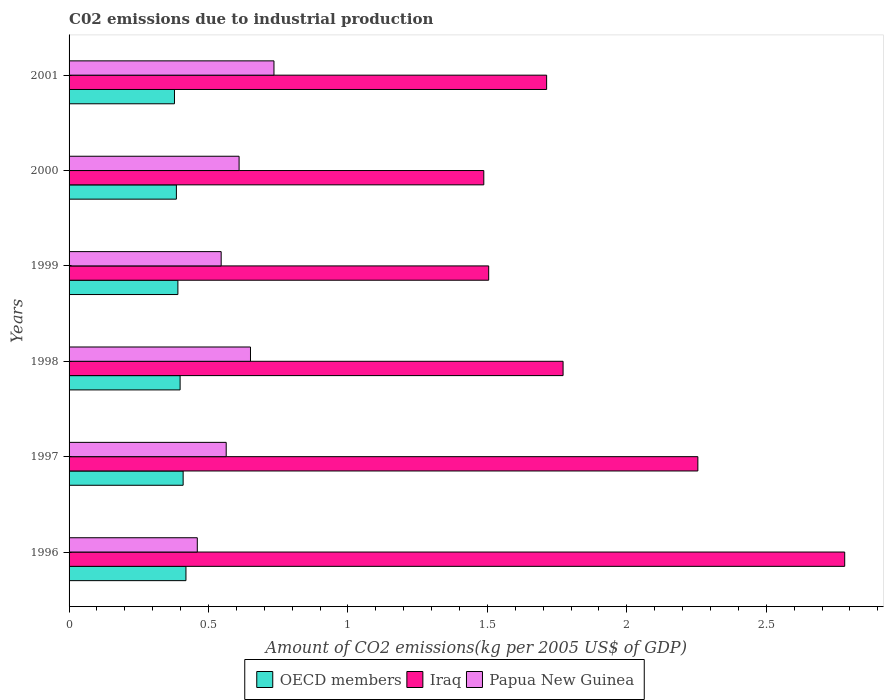How many different coloured bars are there?
Your answer should be very brief. 3. How many groups of bars are there?
Offer a terse response. 6. Are the number of bars per tick equal to the number of legend labels?
Make the answer very short. Yes. How many bars are there on the 1st tick from the top?
Offer a very short reply. 3. How many bars are there on the 1st tick from the bottom?
Your answer should be compact. 3. What is the amount of CO2 emitted due to industrial production in OECD members in 1999?
Your response must be concise. 0.39. Across all years, what is the maximum amount of CO2 emitted due to industrial production in Papua New Guinea?
Give a very brief answer. 0.73. Across all years, what is the minimum amount of CO2 emitted due to industrial production in Papua New Guinea?
Make the answer very short. 0.46. In which year was the amount of CO2 emitted due to industrial production in Iraq maximum?
Offer a terse response. 1996. In which year was the amount of CO2 emitted due to industrial production in Iraq minimum?
Provide a short and direct response. 2000. What is the total amount of CO2 emitted due to industrial production in OECD members in the graph?
Provide a succinct answer. 2.38. What is the difference between the amount of CO2 emitted due to industrial production in Papua New Guinea in 1997 and that in 1998?
Offer a terse response. -0.09. What is the difference between the amount of CO2 emitted due to industrial production in OECD members in 2000 and the amount of CO2 emitted due to industrial production in Papua New Guinea in 1997?
Offer a very short reply. -0.18. What is the average amount of CO2 emitted due to industrial production in OECD members per year?
Offer a terse response. 0.4. In the year 1998, what is the difference between the amount of CO2 emitted due to industrial production in Papua New Guinea and amount of CO2 emitted due to industrial production in OECD members?
Offer a terse response. 0.25. In how many years, is the amount of CO2 emitted due to industrial production in Iraq greater than 2.2 kg?
Your answer should be compact. 2. What is the ratio of the amount of CO2 emitted due to industrial production in Iraq in 1997 to that in 2001?
Provide a short and direct response. 1.32. Is the amount of CO2 emitted due to industrial production in Iraq in 1997 less than that in 1999?
Keep it short and to the point. No. Is the difference between the amount of CO2 emitted due to industrial production in Papua New Guinea in 1997 and 2001 greater than the difference between the amount of CO2 emitted due to industrial production in OECD members in 1997 and 2001?
Offer a very short reply. No. What is the difference between the highest and the second highest amount of CO2 emitted due to industrial production in Iraq?
Ensure brevity in your answer.  0.53. What is the difference between the highest and the lowest amount of CO2 emitted due to industrial production in OECD members?
Keep it short and to the point. 0.04. Is the sum of the amount of CO2 emitted due to industrial production in Papua New Guinea in 1996 and 1998 greater than the maximum amount of CO2 emitted due to industrial production in OECD members across all years?
Your answer should be very brief. Yes. What does the 1st bar from the top in 1997 represents?
Provide a short and direct response. Papua New Guinea. What does the 1st bar from the bottom in 1997 represents?
Your answer should be compact. OECD members. How many bars are there?
Your response must be concise. 18. Are all the bars in the graph horizontal?
Give a very brief answer. Yes. Does the graph contain grids?
Ensure brevity in your answer.  No. What is the title of the graph?
Your response must be concise. C02 emissions due to industrial production. What is the label or title of the X-axis?
Offer a very short reply. Amount of CO2 emissions(kg per 2005 US$ of GDP). What is the Amount of CO2 emissions(kg per 2005 US$ of GDP) in OECD members in 1996?
Keep it short and to the point. 0.42. What is the Amount of CO2 emissions(kg per 2005 US$ of GDP) in Iraq in 1996?
Offer a very short reply. 2.78. What is the Amount of CO2 emissions(kg per 2005 US$ of GDP) of Papua New Guinea in 1996?
Provide a succinct answer. 0.46. What is the Amount of CO2 emissions(kg per 2005 US$ of GDP) of OECD members in 1997?
Ensure brevity in your answer.  0.41. What is the Amount of CO2 emissions(kg per 2005 US$ of GDP) of Iraq in 1997?
Keep it short and to the point. 2.25. What is the Amount of CO2 emissions(kg per 2005 US$ of GDP) in Papua New Guinea in 1997?
Offer a very short reply. 0.56. What is the Amount of CO2 emissions(kg per 2005 US$ of GDP) in OECD members in 1998?
Offer a terse response. 0.4. What is the Amount of CO2 emissions(kg per 2005 US$ of GDP) of Iraq in 1998?
Your answer should be very brief. 1.77. What is the Amount of CO2 emissions(kg per 2005 US$ of GDP) in Papua New Guinea in 1998?
Your answer should be very brief. 0.65. What is the Amount of CO2 emissions(kg per 2005 US$ of GDP) of OECD members in 1999?
Your answer should be compact. 0.39. What is the Amount of CO2 emissions(kg per 2005 US$ of GDP) of Iraq in 1999?
Provide a succinct answer. 1.5. What is the Amount of CO2 emissions(kg per 2005 US$ of GDP) of Papua New Guinea in 1999?
Your response must be concise. 0.55. What is the Amount of CO2 emissions(kg per 2005 US$ of GDP) in OECD members in 2000?
Your response must be concise. 0.38. What is the Amount of CO2 emissions(kg per 2005 US$ of GDP) of Iraq in 2000?
Offer a terse response. 1.49. What is the Amount of CO2 emissions(kg per 2005 US$ of GDP) of Papua New Guinea in 2000?
Ensure brevity in your answer.  0.61. What is the Amount of CO2 emissions(kg per 2005 US$ of GDP) in OECD members in 2001?
Provide a succinct answer. 0.38. What is the Amount of CO2 emissions(kg per 2005 US$ of GDP) of Iraq in 2001?
Your answer should be compact. 1.71. What is the Amount of CO2 emissions(kg per 2005 US$ of GDP) of Papua New Guinea in 2001?
Make the answer very short. 0.73. Across all years, what is the maximum Amount of CO2 emissions(kg per 2005 US$ of GDP) of OECD members?
Make the answer very short. 0.42. Across all years, what is the maximum Amount of CO2 emissions(kg per 2005 US$ of GDP) of Iraq?
Your answer should be very brief. 2.78. Across all years, what is the maximum Amount of CO2 emissions(kg per 2005 US$ of GDP) in Papua New Guinea?
Provide a short and direct response. 0.73. Across all years, what is the minimum Amount of CO2 emissions(kg per 2005 US$ of GDP) of OECD members?
Your answer should be compact. 0.38. Across all years, what is the minimum Amount of CO2 emissions(kg per 2005 US$ of GDP) in Iraq?
Offer a terse response. 1.49. Across all years, what is the minimum Amount of CO2 emissions(kg per 2005 US$ of GDP) in Papua New Guinea?
Your answer should be compact. 0.46. What is the total Amount of CO2 emissions(kg per 2005 US$ of GDP) of OECD members in the graph?
Provide a short and direct response. 2.38. What is the total Amount of CO2 emissions(kg per 2005 US$ of GDP) of Iraq in the graph?
Offer a terse response. 11.51. What is the total Amount of CO2 emissions(kg per 2005 US$ of GDP) of Papua New Guinea in the graph?
Your response must be concise. 3.56. What is the difference between the Amount of CO2 emissions(kg per 2005 US$ of GDP) in OECD members in 1996 and that in 1997?
Keep it short and to the point. 0.01. What is the difference between the Amount of CO2 emissions(kg per 2005 US$ of GDP) in Iraq in 1996 and that in 1997?
Your response must be concise. 0.53. What is the difference between the Amount of CO2 emissions(kg per 2005 US$ of GDP) of Papua New Guinea in 1996 and that in 1997?
Provide a succinct answer. -0.1. What is the difference between the Amount of CO2 emissions(kg per 2005 US$ of GDP) in OECD members in 1996 and that in 1998?
Provide a short and direct response. 0.02. What is the difference between the Amount of CO2 emissions(kg per 2005 US$ of GDP) of Iraq in 1996 and that in 1998?
Ensure brevity in your answer.  1.01. What is the difference between the Amount of CO2 emissions(kg per 2005 US$ of GDP) of Papua New Guinea in 1996 and that in 1998?
Offer a terse response. -0.19. What is the difference between the Amount of CO2 emissions(kg per 2005 US$ of GDP) in OECD members in 1996 and that in 1999?
Ensure brevity in your answer.  0.03. What is the difference between the Amount of CO2 emissions(kg per 2005 US$ of GDP) in Iraq in 1996 and that in 1999?
Your response must be concise. 1.28. What is the difference between the Amount of CO2 emissions(kg per 2005 US$ of GDP) of Papua New Guinea in 1996 and that in 1999?
Your answer should be compact. -0.09. What is the difference between the Amount of CO2 emissions(kg per 2005 US$ of GDP) of OECD members in 1996 and that in 2000?
Keep it short and to the point. 0.03. What is the difference between the Amount of CO2 emissions(kg per 2005 US$ of GDP) in Iraq in 1996 and that in 2000?
Your response must be concise. 1.29. What is the difference between the Amount of CO2 emissions(kg per 2005 US$ of GDP) of Papua New Guinea in 1996 and that in 2000?
Ensure brevity in your answer.  -0.15. What is the difference between the Amount of CO2 emissions(kg per 2005 US$ of GDP) in OECD members in 1996 and that in 2001?
Your answer should be very brief. 0.04. What is the difference between the Amount of CO2 emissions(kg per 2005 US$ of GDP) of Iraq in 1996 and that in 2001?
Provide a succinct answer. 1.07. What is the difference between the Amount of CO2 emissions(kg per 2005 US$ of GDP) in Papua New Guinea in 1996 and that in 2001?
Offer a terse response. -0.27. What is the difference between the Amount of CO2 emissions(kg per 2005 US$ of GDP) in OECD members in 1997 and that in 1998?
Offer a terse response. 0.01. What is the difference between the Amount of CO2 emissions(kg per 2005 US$ of GDP) of Iraq in 1997 and that in 1998?
Keep it short and to the point. 0.48. What is the difference between the Amount of CO2 emissions(kg per 2005 US$ of GDP) in Papua New Guinea in 1997 and that in 1998?
Keep it short and to the point. -0.09. What is the difference between the Amount of CO2 emissions(kg per 2005 US$ of GDP) in OECD members in 1997 and that in 1999?
Give a very brief answer. 0.02. What is the difference between the Amount of CO2 emissions(kg per 2005 US$ of GDP) in Iraq in 1997 and that in 1999?
Ensure brevity in your answer.  0.75. What is the difference between the Amount of CO2 emissions(kg per 2005 US$ of GDP) of Papua New Guinea in 1997 and that in 1999?
Your answer should be compact. 0.02. What is the difference between the Amount of CO2 emissions(kg per 2005 US$ of GDP) in OECD members in 1997 and that in 2000?
Offer a very short reply. 0.02. What is the difference between the Amount of CO2 emissions(kg per 2005 US$ of GDP) in Iraq in 1997 and that in 2000?
Give a very brief answer. 0.77. What is the difference between the Amount of CO2 emissions(kg per 2005 US$ of GDP) of Papua New Guinea in 1997 and that in 2000?
Offer a terse response. -0.05. What is the difference between the Amount of CO2 emissions(kg per 2005 US$ of GDP) in OECD members in 1997 and that in 2001?
Offer a terse response. 0.03. What is the difference between the Amount of CO2 emissions(kg per 2005 US$ of GDP) of Iraq in 1997 and that in 2001?
Make the answer very short. 0.54. What is the difference between the Amount of CO2 emissions(kg per 2005 US$ of GDP) of Papua New Guinea in 1997 and that in 2001?
Your answer should be very brief. -0.17. What is the difference between the Amount of CO2 emissions(kg per 2005 US$ of GDP) of OECD members in 1998 and that in 1999?
Keep it short and to the point. 0.01. What is the difference between the Amount of CO2 emissions(kg per 2005 US$ of GDP) in Iraq in 1998 and that in 1999?
Your answer should be very brief. 0.27. What is the difference between the Amount of CO2 emissions(kg per 2005 US$ of GDP) of Papua New Guinea in 1998 and that in 1999?
Make the answer very short. 0.11. What is the difference between the Amount of CO2 emissions(kg per 2005 US$ of GDP) of OECD members in 1998 and that in 2000?
Your response must be concise. 0.01. What is the difference between the Amount of CO2 emissions(kg per 2005 US$ of GDP) of Iraq in 1998 and that in 2000?
Your response must be concise. 0.28. What is the difference between the Amount of CO2 emissions(kg per 2005 US$ of GDP) in Papua New Guinea in 1998 and that in 2000?
Offer a very short reply. 0.04. What is the difference between the Amount of CO2 emissions(kg per 2005 US$ of GDP) of OECD members in 1998 and that in 2001?
Offer a terse response. 0.02. What is the difference between the Amount of CO2 emissions(kg per 2005 US$ of GDP) of Iraq in 1998 and that in 2001?
Make the answer very short. 0.06. What is the difference between the Amount of CO2 emissions(kg per 2005 US$ of GDP) of Papua New Guinea in 1998 and that in 2001?
Offer a very short reply. -0.08. What is the difference between the Amount of CO2 emissions(kg per 2005 US$ of GDP) of OECD members in 1999 and that in 2000?
Your answer should be very brief. 0.01. What is the difference between the Amount of CO2 emissions(kg per 2005 US$ of GDP) in Iraq in 1999 and that in 2000?
Your response must be concise. 0.02. What is the difference between the Amount of CO2 emissions(kg per 2005 US$ of GDP) of Papua New Guinea in 1999 and that in 2000?
Offer a terse response. -0.06. What is the difference between the Amount of CO2 emissions(kg per 2005 US$ of GDP) in OECD members in 1999 and that in 2001?
Give a very brief answer. 0.01. What is the difference between the Amount of CO2 emissions(kg per 2005 US$ of GDP) of Iraq in 1999 and that in 2001?
Your answer should be compact. -0.21. What is the difference between the Amount of CO2 emissions(kg per 2005 US$ of GDP) in Papua New Guinea in 1999 and that in 2001?
Offer a very short reply. -0.19. What is the difference between the Amount of CO2 emissions(kg per 2005 US$ of GDP) of OECD members in 2000 and that in 2001?
Ensure brevity in your answer.  0.01. What is the difference between the Amount of CO2 emissions(kg per 2005 US$ of GDP) in Iraq in 2000 and that in 2001?
Your answer should be very brief. -0.23. What is the difference between the Amount of CO2 emissions(kg per 2005 US$ of GDP) of Papua New Guinea in 2000 and that in 2001?
Your answer should be compact. -0.12. What is the difference between the Amount of CO2 emissions(kg per 2005 US$ of GDP) in OECD members in 1996 and the Amount of CO2 emissions(kg per 2005 US$ of GDP) in Iraq in 1997?
Ensure brevity in your answer.  -1.84. What is the difference between the Amount of CO2 emissions(kg per 2005 US$ of GDP) of OECD members in 1996 and the Amount of CO2 emissions(kg per 2005 US$ of GDP) of Papua New Guinea in 1997?
Offer a terse response. -0.14. What is the difference between the Amount of CO2 emissions(kg per 2005 US$ of GDP) in Iraq in 1996 and the Amount of CO2 emissions(kg per 2005 US$ of GDP) in Papua New Guinea in 1997?
Offer a very short reply. 2.22. What is the difference between the Amount of CO2 emissions(kg per 2005 US$ of GDP) in OECD members in 1996 and the Amount of CO2 emissions(kg per 2005 US$ of GDP) in Iraq in 1998?
Offer a very short reply. -1.35. What is the difference between the Amount of CO2 emissions(kg per 2005 US$ of GDP) in OECD members in 1996 and the Amount of CO2 emissions(kg per 2005 US$ of GDP) in Papua New Guinea in 1998?
Your answer should be very brief. -0.23. What is the difference between the Amount of CO2 emissions(kg per 2005 US$ of GDP) of Iraq in 1996 and the Amount of CO2 emissions(kg per 2005 US$ of GDP) of Papua New Guinea in 1998?
Provide a short and direct response. 2.13. What is the difference between the Amount of CO2 emissions(kg per 2005 US$ of GDP) in OECD members in 1996 and the Amount of CO2 emissions(kg per 2005 US$ of GDP) in Iraq in 1999?
Provide a short and direct response. -1.09. What is the difference between the Amount of CO2 emissions(kg per 2005 US$ of GDP) in OECD members in 1996 and the Amount of CO2 emissions(kg per 2005 US$ of GDP) in Papua New Guinea in 1999?
Your answer should be very brief. -0.13. What is the difference between the Amount of CO2 emissions(kg per 2005 US$ of GDP) in Iraq in 1996 and the Amount of CO2 emissions(kg per 2005 US$ of GDP) in Papua New Guinea in 1999?
Keep it short and to the point. 2.24. What is the difference between the Amount of CO2 emissions(kg per 2005 US$ of GDP) of OECD members in 1996 and the Amount of CO2 emissions(kg per 2005 US$ of GDP) of Iraq in 2000?
Ensure brevity in your answer.  -1.07. What is the difference between the Amount of CO2 emissions(kg per 2005 US$ of GDP) of OECD members in 1996 and the Amount of CO2 emissions(kg per 2005 US$ of GDP) of Papua New Guinea in 2000?
Offer a terse response. -0.19. What is the difference between the Amount of CO2 emissions(kg per 2005 US$ of GDP) in Iraq in 1996 and the Amount of CO2 emissions(kg per 2005 US$ of GDP) in Papua New Guinea in 2000?
Keep it short and to the point. 2.17. What is the difference between the Amount of CO2 emissions(kg per 2005 US$ of GDP) in OECD members in 1996 and the Amount of CO2 emissions(kg per 2005 US$ of GDP) in Iraq in 2001?
Ensure brevity in your answer.  -1.29. What is the difference between the Amount of CO2 emissions(kg per 2005 US$ of GDP) in OECD members in 1996 and the Amount of CO2 emissions(kg per 2005 US$ of GDP) in Papua New Guinea in 2001?
Provide a succinct answer. -0.32. What is the difference between the Amount of CO2 emissions(kg per 2005 US$ of GDP) in Iraq in 1996 and the Amount of CO2 emissions(kg per 2005 US$ of GDP) in Papua New Guinea in 2001?
Provide a short and direct response. 2.05. What is the difference between the Amount of CO2 emissions(kg per 2005 US$ of GDP) of OECD members in 1997 and the Amount of CO2 emissions(kg per 2005 US$ of GDP) of Iraq in 1998?
Keep it short and to the point. -1.36. What is the difference between the Amount of CO2 emissions(kg per 2005 US$ of GDP) in OECD members in 1997 and the Amount of CO2 emissions(kg per 2005 US$ of GDP) in Papua New Guinea in 1998?
Offer a very short reply. -0.24. What is the difference between the Amount of CO2 emissions(kg per 2005 US$ of GDP) in Iraq in 1997 and the Amount of CO2 emissions(kg per 2005 US$ of GDP) in Papua New Guinea in 1998?
Make the answer very short. 1.6. What is the difference between the Amount of CO2 emissions(kg per 2005 US$ of GDP) of OECD members in 1997 and the Amount of CO2 emissions(kg per 2005 US$ of GDP) of Iraq in 1999?
Your answer should be very brief. -1.1. What is the difference between the Amount of CO2 emissions(kg per 2005 US$ of GDP) of OECD members in 1997 and the Amount of CO2 emissions(kg per 2005 US$ of GDP) of Papua New Guinea in 1999?
Your response must be concise. -0.14. What is the difference between the Amount of CO2 emissions(kg per 2005 US$ of GDP) in Iraq in 1997 and the Amount of CO2 emissions(kg per 2005 US$ of GDP) in Papua New Guinea in 1999?
Offer a very short reply. 1.71. What is the difference between the Amount of CO2 emissions(kg per 2005 US$ of GDP) of OECD members in 1997 and the Amount of CO2 emissions(kg per 2005 US$ of GDP) of Iraq in 2000?
Your answer should be compact. -1.08. What is the difference between the Amount of CO2 emissions(kg per 2005 US$ of GDP) in OECD members in 1997 and the Amount of CO2 emissions(kg per 2005 US$ of GDP) in Papua New Guinea in 2000?
Keep it short and to the point. -0.2. What is the difference between the Amount of CO2 emissions(kg per 2005 US$ of GDP) of Iraq in 1997 and the Amount of CO2 emissions(kg per 2005 US$ of GDP) of Papua New Guinea in 2000?
Your answer should be very brief. 1.65. What is the difference between the Amount of CO2 emissions(kg per 2005 US$ of GDP) in OECD members in 1997 and the Amount of CO2 emissions(kg per 2005 US$ of GDP) in Iraq in 2001?
Offer a very short reply. -1.3. What is the difference between the Amount of CO2 emissions(kg per 2005 US$ of GDP) in OECD members in 1997 and the Amount of CO2 emissions(kg per 2005 US$ of GDP) in Papua New Guinea in 2001?
Provide a short and direct response. -0.33. What is the difference between the Amount of CO2 emissions(kg per 2005 US$ of GDP) of Iraq in 1997 and the Amount of CO2 emissions(kg per 2005 US$ of GDP) of Papua New Guinea in 2001?
Offer a very short reply. 1.52. What is the difference between the Amount of CO2 emissions(kg per 2005 US$ of GDP) of OECD members in 1998 and the Amount of CO2 emissions(kg per 2005 US$ of GDP) of Iraq in 1999?
Ensure brevity in your answer.  -1.11. What is the difference between the Amount of CO2 emissions(kg per 2005 US$ of GDP) in OECD members in 1998 and the Amount of CO2 emissions(kg per 2005 US$ of GDP) in Papua New Guinea in 1999?
Your answer should be very brief. -0.15. What is the difference between the Amount of CO2 emissions(kg per 2005 US$ of GDP) of Iraq in 1998 and the Amount of CO2 emissions(kg per 2005 US$ of GDP) of Papua New Guinea in 1999?
Make the answer very short. 1.23. What is the difference between the Amount of CO2 emissions(kg per 2005 US$ of GDP) in OECD members in 1998 and the Amount of CO2 emissions(kg per 2005 US$ of GDP) in Iraq in 2000?
Offer a terse response. -1.09. What is the difference between the Amount of CO2 emissions(kg per 2005 US$ of GDP) in OECD members in 1998 and the Amount of CO2 emissions(kg per 2005 US$ of GDP) in Papua New Guinea in 2000?
Offer a terse response. -0.21. What is the difference between the Amount of CO2 emissions(kg per 2005 US$ of GDP) in Iraq in 1998 and the Amount of CO2 emissions(kg per 2005 US$ of GDP) in Papua New Guinea in 2000?
Provide a short and direct response. 1.16. What is the difference between the Amount of CO2 emissions(kg per 2005 US$ of GDP) of OECD members in 1998 and the Amount of CO2 emissions(kg per 2005 US$ of GDP) of Iraq in 2001?
Your response must be concise. -1.31. What is the difference between the Amount of CO2 emissions(kg per 2005 US$ of GDP) of OECD members in 1998 and the Amount of CO2 emissions(kg per 2005 US$ of GDP) of Papua New Guinea in 2001?
Offer a very short reply. -0.34. What is the difference between the Amount of CO2 emissions(kg per 2005 US$ of GDP) of Iraq in 1998 and the Amount of CO2 emissions(kg per 2005 US$ of GDP) of Papua New Guinea in 2001?
Provide a short and direct response. 1.04. What is the difference between the Amount of CO2 emissions(kg per 2005 US$ of GDP) of OECD members in 1999 and the Amount of CO2 emissions(kg per 2005 US$ of GDP) of Iraq in 2000?
Your answer should be compact. -1.1. What is the difference between the Amount of CO2 emissions(kg per 2005 US$ of GDP) of OECD members in 1999 and the Amount of CO2 emissions(kg per 2005 US$ of GDP) of Papua New Guinea in 2000?
Offer a very short reply. -0.22. What is the difference between the Amount of CO2 emissions(kg per 2005 US$ of GDP) in Iraq in 1999 and the Amount of CO2 emissions(kg per 2005 US$ of GDP) in Papua New Guinea in 2000?
Offer a terse response. 0.9. What is the difference between the Amount of CO2 emissions(kg per 2005 US$ of GDP) in OECD members in 1999 and the Amount of CO2 emissions(kg per 2005 US$ of GDP) in Iraq in 2001?
Your answer should be compact. -1.32. What is the difference between the Amount of CO2 emissions(kg per 2005 US$ of GDP) in OECD members in 1999 and the Amount of CO2 emissions(kg per 2005 US$ of GDP) in Papua New Guinea in 2001?
Ensure brevity in your answer.  -0.34. What is the difference between the Amount of CO2 emissions(kg per 2005 US$ of GDP) of Iraq in 1999 and the Amount of CO2 emissions(kg per 2005 US$ of GDP) of Papua New Guinea in 2001?
Give a very brief answer. 0.77. What is the difference between the Amount of CO2 emissions(kg per 2005 US$ of GDP) of OECD members in 2000 and the Amount of CO2 emissions(kg per 2005 US$ of GDP) of Iraq in 2001?
Your answer should be compact. -1.33. What is the difference between the Amount of CO2 emissions(kg per 2005 US$ of GDP) in OECD members in 2000 and the Amount of CO2 emissions(kg per 2005 US$ of GDP) in Papua New Guinea in 2001?
Offer a very short reply. -0.35. What is the difference between the Amount of CO2 emissions(kg per 2005 US$ of GDP) of Iraq in 2000 and the Amount of CO2 emissions(kg per 2005 US$ of GDP) of Papua New Guinea in 2001?
Your response must be concise. 0.75. What is the average Amount of CO2 emissions(kg per 2005 US$ of GDP) in OECD members per year?
Your answer should be compact. 0.4. What is the average Amount of CO2 emissions(kg per 2005 US$ of GDP) in Iraq per year?
Your answer should be very brief. 1.92. What is the average Amount of CO2 emissions(kg per 2005 US$ of GDP) in Papua New Guinea per year?
Provide a succinct answer. 0.59. In the year 1996, what is the difference between the Amount of CO2 emissions(kg per 2005 US$ of GDP) of OECD members and Amount of CO2 emissions(kg per 2005 US$ of GDP) of Iraq?
Keep it short and to the point. -2.36. In the year 1996, what is the difference between the Amount of CO2 emissions(kg per 2005 US$ of GDP) of OECD members and Amount of CO2 emissions(kg per 2005 US$ of GDP) of Papua New Guinea?
Make the answer very short. -0.04. In the year 1996, what is the difference between the Amount of CO2 emissions(kg per 2005 US$ of GDP) in Iraq and Amount of CO2 emissions(kg per 2005 US$ of GDP) in Papua New Guinea?
Offer a terse response. 2.32. In the year 1997, what is the difference between the Amount of CO2 emissions(kg per 2005 US$ of GDP) of OECD members and Amount of CO2 emissions(kg per 2005 US$ of GDP) of Iraq?
Keep it short and to the point. -1.85. In the year 1997, what is the difference between the Amount of CO2 emissions(kg per 2005 US$ of GDP) in OECD members and Amount of CO2 emissions(kg per 2005 US$ of GDP) in Papua New Guinea?
Ensure brevity in your answer.  -0.15. In the year 1997, what is the difference between the Amount of CO2 emissions(kg per 2005 US$ of GDP) in Iraq and Amount of CO2 emissions(kg per 2005 US$ of GDP) in Papua New Guinea?
Ensure brevity in your answer.  1.69. In the year 1998, what is the difference between the Amount of CO2 emissions(kg per 2005 US$ of GDP) of OECD members and Amount of CO2 emissions(kg per 2005 US$ of GDP) of Iraq?
Make the answer very short. -1.37. In the year 1998, what is the difference between the Amount of CO2 emissions(kg per 2005 US$ of GDP) in OECD members and Amount of CO2 emissions(kg per 2005 US$ of GDP) in Papua New Guinea?
Offer a very short reply. -0.25. In the year 1998, what is the difference between the Amount of CO2 emissions(kg per 2005 US$ of GDP) in Iraq and Amount of CO2 emissions(kg per 2005 US$ of GDP) in Papua New Guinea?
Keep it short and to the point. 1.12. In the year 1999, what is the difference between the Amount of CO2 emissions(kg per 2005 US$ of GDP) of OECD members and Amount of CO2 emissions(kg per 2005 US$ of GDP) of Iraq?
Provide a succinct answer. -1.11. In the year 1999, what is the difference between the Amount of CO2 emissions(kg per 2005 US$ of GDP) of OECD members and Amount of CO2 emissions(kg per 2005 US$ of GDP) of Papua New Guinea?
Your answer should be compact. -0.16. In the year 1999, what is the difference between the Amount of CO2 emissions(kg per 2005 US$ of GDP) in Iraq and Amount of CO2 emissions(kg per 2005 US$ of GDP) in Papua New Guinea?
Offer a terse response. 0.96. In the year 2000, what is the difference between the Amount of CO2 emissions(kg per 2005 US$ of GDP) in OECD members and Amount of CO2 emissions(kg per 2005 US$ of GDP) in Iraq?
Your answer should be compact. -1.1. In the year 2000, what is the difference between the Amount of CO2 emissions(kg per 2005 US$ of GDP) in OECD members and Amount of CO2 emissions(kg per 2005 US$ of GDP) in Papua New Guinea?
Give a very brief answer. -0.22. In the year 2000, what is the difference between the Amount of CO2 emissions(kg per 2005 US$ of GDP) of Iraq and Amount of CO2 emissions(kg per 2005 US$ of GDP) of Papua New Guinea?
Your answer should be very brief. 0.88. In the year 2001, what is the difference between the Amount of CO2 emissions(kg per 2005 US$ of GDP) of OECD members and Amount of CO2 emissions(kg per 2005 US$ of GDP) of Iraq?
Offer a terse response. -1.33. In the year 2001, what is the difference between the Amount of CO2 emissions(kg per 2005 US$ of GDP) in OECD members and Amount of CO2 emissions(kg per 2005 US$ of GDP) in Papua New Guinea?
Offer a very short reply. -0.36. In the year 2001, what is the difference between the Amount of CO2 emissions(kg per 2005 US$ of GDP) of Iraq and Amount of CO2 emissions(kg per 2005 US$ of GDP) of Papua New Guinea?
Provide a short and direct response. 0.98. What is the ratio of the Amount of CO2 emissions(kg per 2005 US$ of GDP) in OECD members in 1996 to that in 1997?
Provide a succinct answer. 1.02. What is the ratio of the Amount of CO2 emissions(kg per 2005 US$ of GDP) of Iraq in 1996 to that in 1997?
Offer a very short reply. 1.23. What is the ratio of the Amount of CO2 emissions(kg per 2005 US$ of GDP) of Papua New Guinea in 1996 to that in 1997?
Your answer should be compact. 0.82. What is the ratio of the Amount of CO2 emissions(kg per 2005 US$ of GDP) in OECD members in 1996 to that in 1998?
Ensure brevity in your answer.  1.05. What is the ratio of the Amount of CO2 emissions(kg per 2005 US$ of GDP) of Iraq in 1996 to that in 1998?
Keep it short and to the point. 1.57. What is the ratio of the Amount of CO2 emissions(kg per 2005 US$ of GDP) in Papua New Guinea in 1996 to that in 1998?
Make the answer very short. 0.71. What is the ratio of the Amount of CO2 emissions(kg per 2005 US$ of GDP) of OECD members in 1996 to that in 1999?
Your answer should be compact. 1.07. What is the ratio of the Amount of CO2 emissions(kg per 2005 US$ of GDP) of Iraq in 1996 to that in 1999?
Your answer should be very brief. 1.85. What is the ratio of the Amount of CO2 emissions(kg per 2005 US$ of GDP) in Papua New Guinea in 1996 to that in 1999?
Offer a terse response. 0.84. What is the ratio of the Amount of CO2 emissions(kg per 2005 US$ of GDP) of OECD members in 1996 to that in 2000?
Provide a short and direct response. 1.09. What is the ratio of the Amount of CO2 emissions(kg per 2005 US$ of GDP) in Iraq in 1996 to that in 2000?
Provide a short and direct response. 1.87. What is the ratio of the Amount of CO2 emissions(kg per 2005 US$ of GDP) of Papua New Guinea in 1996 to that in 2000?
Provide a short and direct response. 0.75. What is the ratio of the Amount of CO2 emissions(kg per 2005 US$ of GDP) in OECD members in 1996 to that in 2001?
Your answer should be compact. 1.11. What is the ratio of the Amount of CO2 emissions(kg per 2005 US$ of GDP) in Iraq in 1996 to that in 2001?
Give a very brief answer. 1.62. What is the ratio of the Amount of CO2 emissions(kg per 2005 US$ of GDP) of Papua New Guinea in 1996 to that in 2001?
Your answer should be compact. 0.63. What is the ratio of the Amount of CO2 emissions(kg per 2005 US$ of GDP) in OECD members in 1997 to that in 1998?
Ensure brevity in your answer.  1.03. What is the ratio of the Amount of CO2 emissions(kg per 2005 US$ of GDP) of Iraq in 1997 to that in 1998?
Make the answer very short. 1.27. What is the ratio of the Amount of CO2 emissions(kg per 2005 US$ of GDP) in Papua New Guinea in 1997 to that in 1998?
Keep it short and to the point. 0.87. What is the ratio of the Amount of CO2 emissions(kg per 2005 US$ of GDP) of OECD members in 1997 to that in 1999?
Offer a very short reply. 1.05. What is the ratio of the Amount of CO2 emissions(kg per 2005 US$ of GDP) of Iraq in 1997 to that in 1999?
Make the answer very short. 1.5. What is the ratio of the Amount of CO2 emissions(kg per 2005 US$ of GDP) of Papua New Guinea in 1997 to that in 1999?
Your answer should be very brief. 1.03. What is the ratio of the Amount of CO2 emissions(kg per 2005 US$ of GDP) of OECD members in 1997 to that in 2000?
Make the answer very short. 1.06. What is the ratio of the Amount of CO2 emissions(kg per 2005 US$ of GDP) of Iraq in 1997 to that in 2000?
Keep it short and to the point. 1.52. What is the ratio of the Amount of CO2 emissions(kg per 2005 US$ of GDP) in Papua New Guinea in 1997 to that in 2000?
Your answer should be compact. 0.92. What is the ratio of the Amount of CO2 emissions(kg per 2005 US$ of GDP) of OECD members in 1997 to that in 2001?
Your answer should be very brief. 1.08. What is the ratio of the Amount of CO2 emissions(kg per 2005 US$ of GDP) in Iraq in 1997 to that in 2001?
Offer a very short reply. 1.32. What is the ratio of the Amount of CO2 emissions(kg per 2005 US$ of GDP) of Papua New Guinea in 1997 to that in 2001?
Provide a short and direct response. 0.77. What is the ratio of the Amount of CO2 emissions(kg per 2005 US$ of GDP) of OECD members in 1998 to that in 1999?
Provide a succinct answer. 1.02. What is the ratio of the Amount of CO2 emissions(kg per 2005 US$ of GDP) of Iraq in 1998 to that in 1999?
Keep it short and to the point. 1.18. What is the ratio of the Amount of CO2 emissions(kg per 2005 US$ of GDP) in Papua New Guinea in 1998 to that in 1999?
Make the answer very short. 1.19. What is the ratio of the Amount of CO2 emissions(kg per 2005 US$ of GDP) in OECD members in 1998 to that in 2000?
Your response must be concise. 1.03. What is the ratio of the Amount of CO2 emissions(kg per 2005 US$ of GDP) in Iraq in 1998 to that in 2000?
Provide a succinct answer. 1.19. What is the ratio of the Amount of CO2 emissions(kg per 2005 US$ of GDP) of Papua New Guinea in 1998 to that in 2000?
Your response must be concise. 1.07. What is the ratio of the Amount of CO2 emissions(kg per 2005 US$ of GDP) of OECD members in 1998 to that in 2001?
Ensure brevity in your answer.  1.05. What is the ratio of the Amount of CO2 emissions(kg per 2005 US$ of GDP) in Iraq in 1998 to that in 2001?
Provide a short and direct response. 1.03. What is the ratio of the Amount of CO2 emissions(kg per 2005 US$ of GDP) of Papua New Guinea in 1998 to that in 2001?
Keep it short and to the point. 0.89. What is the ratio of the Amount of CO2 emissions(kg per 2005 US$ of GDP) in OECD members in 1999 to that in 2000?
Keep it short and to the point. 1.01. What is the ratio of the Amount of CO2 emissions(kg per 2005 US$ of GDP) of Iraq in 1999 to that in 2000?
Your answer should be very brief. 1.01. What is the ratio of the Amount of CO2 emissions(kg per 2005 US$ of GDP) in Papua New Guinea in 1999 to that in 2000?
Make the answer very short. 0.89. What is the ratio of the Amount of CO2 emissions(kg per 2005 US$ of GDP) of OECD members in 1999 to that in 2001?
Your response must be concise. 1.03. What is the ratio of the Amount of CO2 emissions(kg per 2005 US$ of GDP) of Iraq in 1999 to that in 2001?
Make the answer very short. 0.88. What is the ratio of the Amount of CO2 emissions(kg per 2005 US$ of GDP) in Papua New Guinea in 1999 to that in 2001?
Offer a terse response. 0.74. What is the ratio of the Amount of CO2 emissions(kg per 2005 US$ of GDP) of OECD members in 2000 to that in 2001?
Your answer should be compact. 1.02. What is the ratio of the Amount of CO2 emissions(kg per 2005 US$ of GDP) of Iraq in 2000 to that in 2001?
Give a very brief answer. 0.87. What is the ratio of the Amount of CO2 emissions(kg per 2005 US$ of GDP) of Papua New Guinea in 2000 to that in 2001?
Offer a very short reply. 0.83. What is the difference between the highest and the second highest Amount of CO2 emissions(kg per 2005 US$ of GDP) in OECD members?
Keep it short and to the point. 0.01. What is the difference between the highest and the second highest Amount of CO2 emissions(kg per 2005 US$ of GDP) in Iraq?
Ensure brevity in your answer.  0.53. What is the difference between the highest and the second highest Amount of CO2 emissions(kg per 2005 US$ of GDP) in Papua New Guinea?
Keep it short and to the point. 0.08. What is the difference between the highest and the lowest Amount of CO2 emissions(kg per 2005 US$ of GDP) in OECD members?
Give a very brief answer. 0.04. What is the difference between the highest and the lowest Amount of CO2 emissions(kg per 2005 US$ of GDP) of Iraq?
Provide a short and direct response. 1.29. What is the difference between the highest and the lowest Amount of CO2 emissions(kg per 2005 US$ of GDP) in Papua New Guinea?
Your answer should be compact. 0.27. 